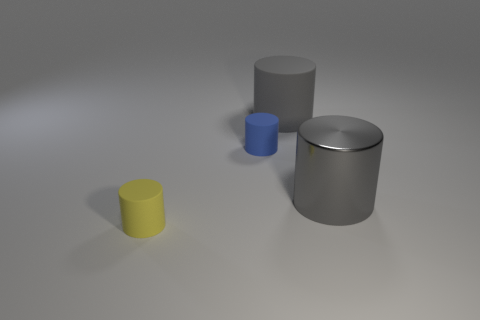Is there a matte cylinder that has the same size as the blue matte thing?
Provide a short and direct response. Yes. Is the size of the gray object behind the gray shiny cylinder the same as the gray shiny cylinder?
Your response must be concise. Yes. Are there more tiny cylinders than rubber cylinders?
Ensure brevity in your answer.  No. Are there any other small objects of the same shape as the blue matte thing?
Ensure brevity in your answer.  Yes. There is a big gray rubber object that is right of the blue object; what shape is it?
Your answer should be compact. Cylinder. There is a tiny matte thing that is behind the rubber cylinder that is in front of the gray metallic thing; what number of tiny yellow rubber objects are on the left side of it?
Provide a succinct answer. 1. Is the color of the big object that is on the right side of the large gray rubber object the same as the big rubber object?
Offer a terse response. Yes. How many other things are there of the same shape as the gray rubber thing?
Make the answer very short. 3. What number of other things are there of the same material as the blue cylinder
Your response must be concise. 2. There is a small thing on the left side of the tiny cylinder behind the tiny object that is in front of the tiny blue object; what is it made of?
Make the answer very short. Rubber. 